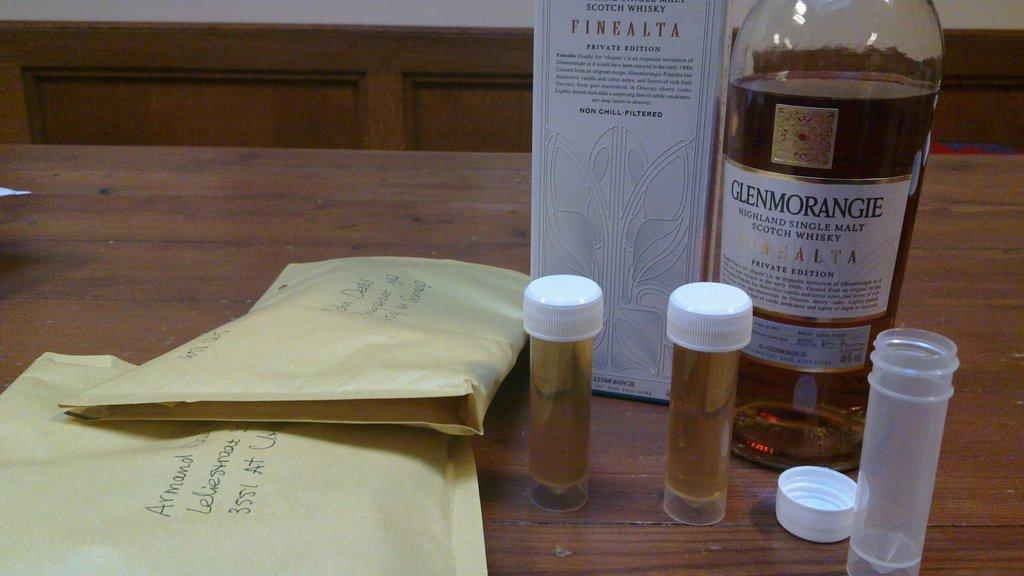<image>
Describe the image concisely. A bottle of Glenmorangie whisky sits on a table near some small vials. 